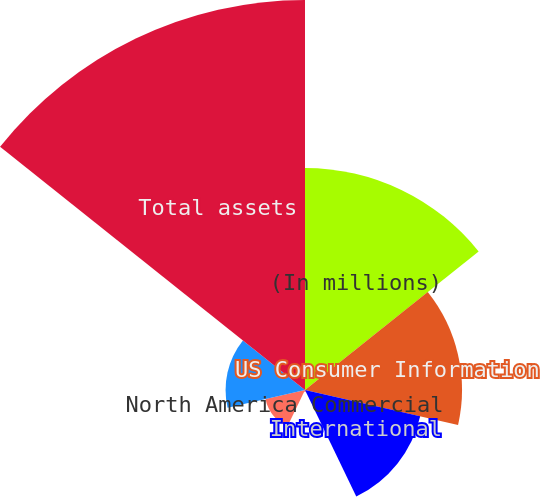Convert chart. <chart><loc_0><loc_0><loc_500><loc_500><pie_chart><fcel>(In millions)<fcel>US Consumer Information<fcel>International<fcel>North America Personal<fcel>North America Commercial<fcel>General Corporate<fcel>Total assets<nl><fcel>22.01%<fcel>15.56%<fcel>11.71%<fcel>0.17%<fcel>4.02%<fcel>7.87%<fcel>38.65%<nl></chart> 